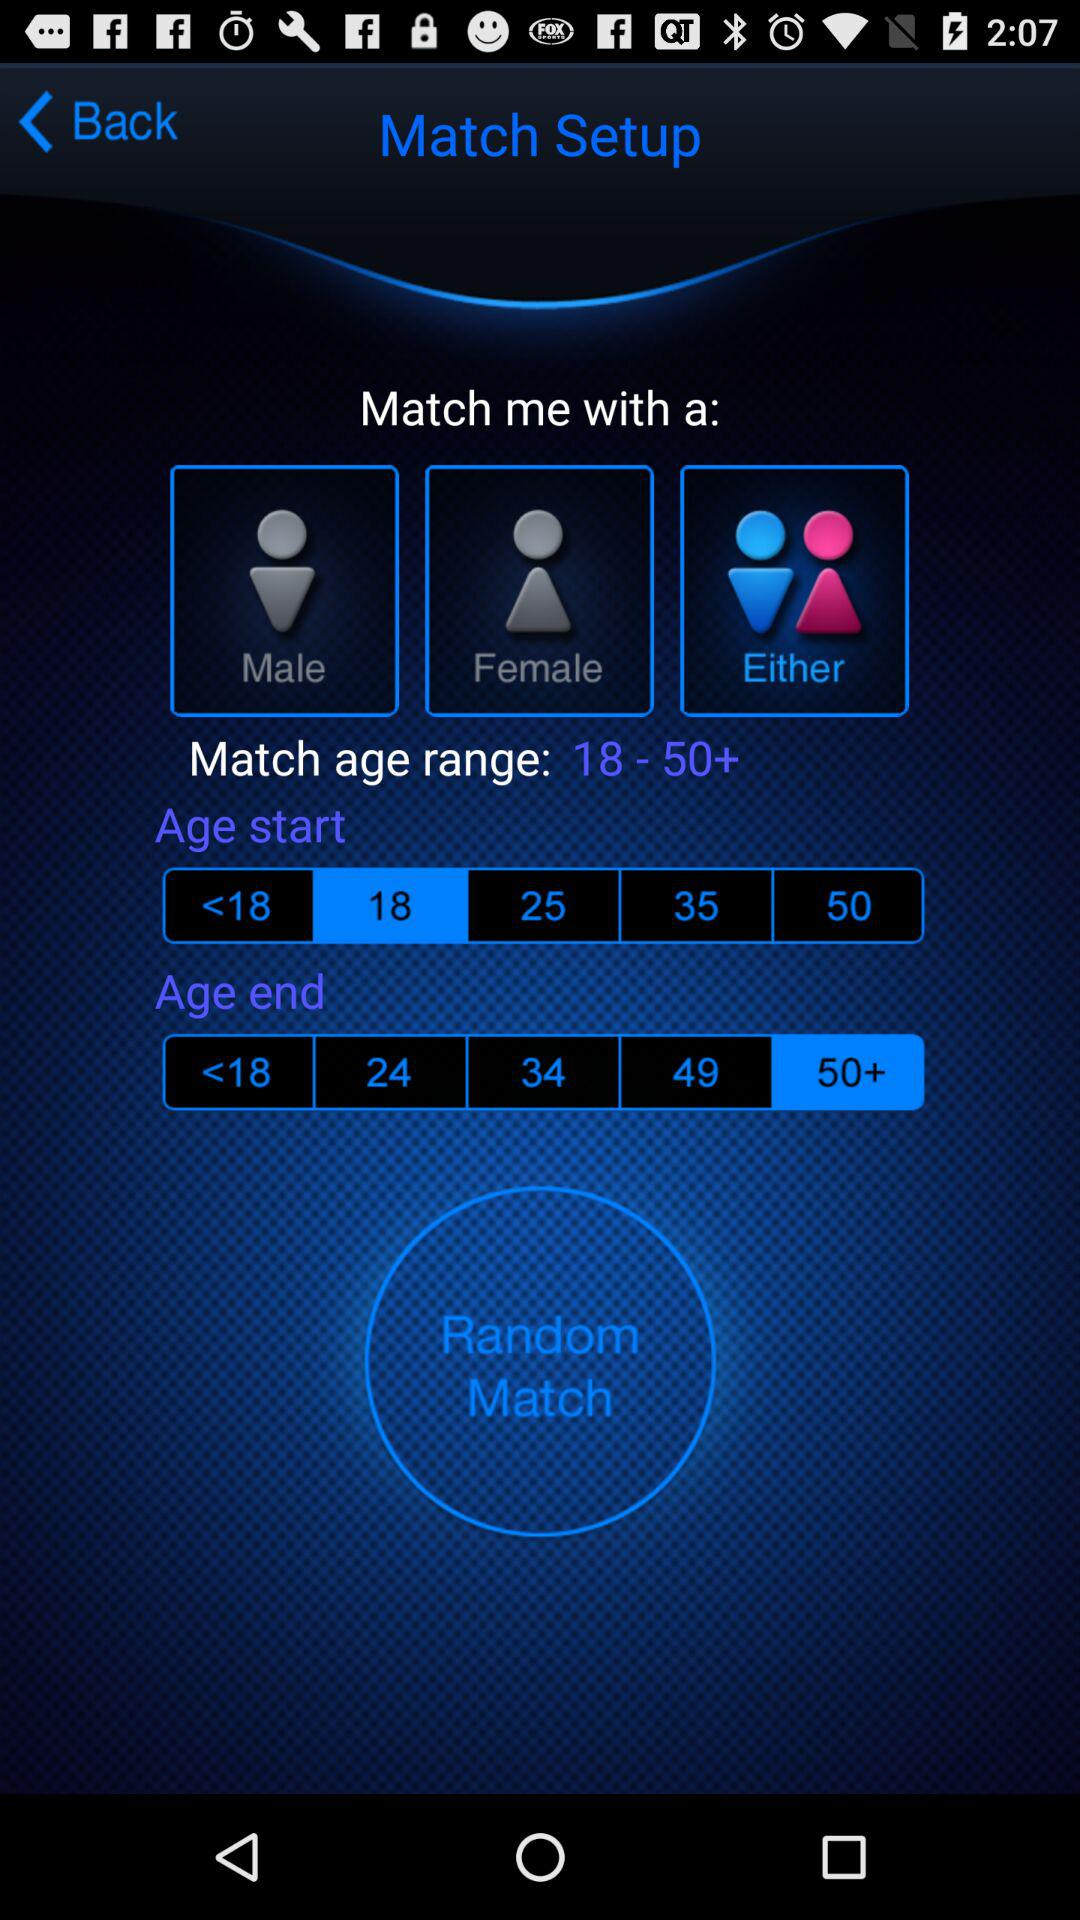What is the selected gender? The selected gender is "Either". 